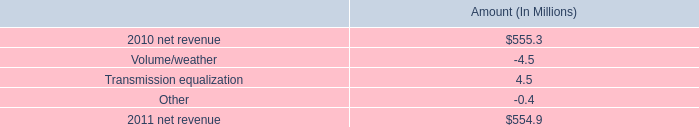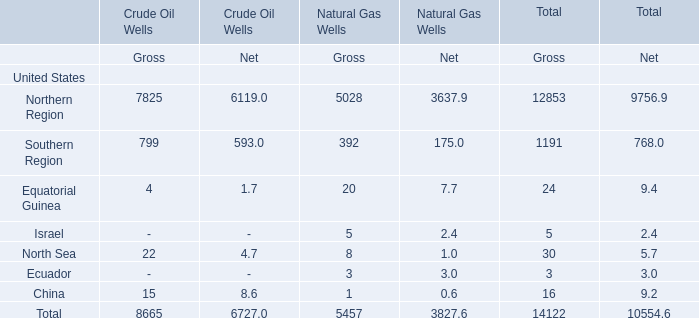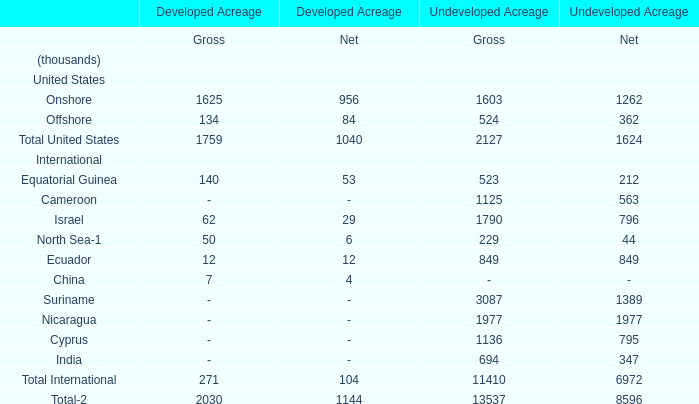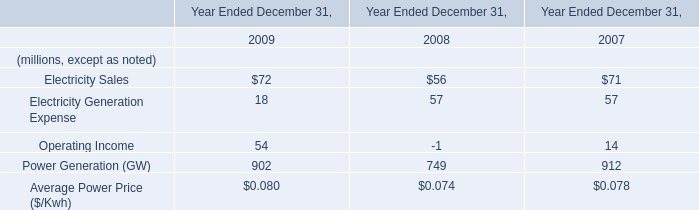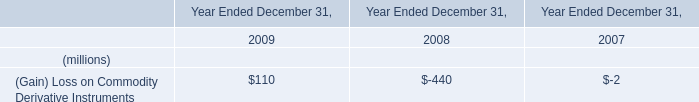What is the ratio of all elements that are in the range of 1600 and 3000 to the sum of elements, for Gross of Undeveloped Acreage? 
Computations: (((1603 + 1790) + 1977) / 13537)
Answer: 0.39669. 